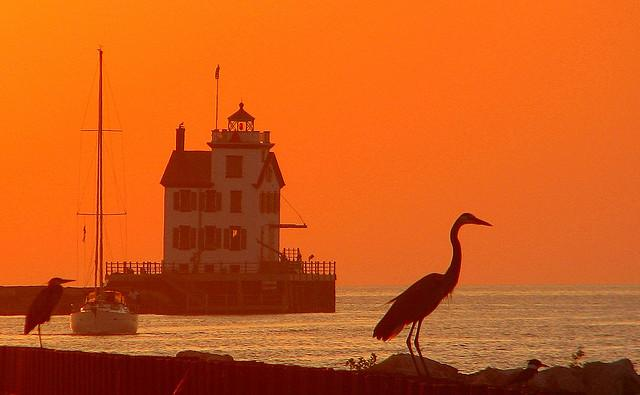What are the birds in front of?

Choices:
A) baby
B) car
C) cow
D) house house 